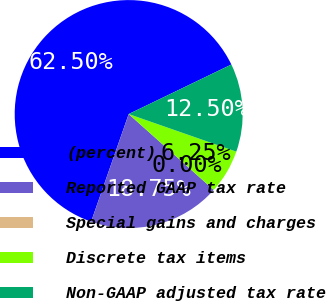Convert chart. <chart><loc_0><loc_0><loc_500><loc_500><pie_chart><fcel>(percent)<fcel>Reported GAAP tax rate<fcel>Special gains and charges<fcel>Discrete tax items<fcel>Non-GAAP adjusted tax rate<nl><fcel>62.49%<fcel>18.75%<fcel>0.0%<fcel>6.25%<fcel>12.5%<nl></chart> 